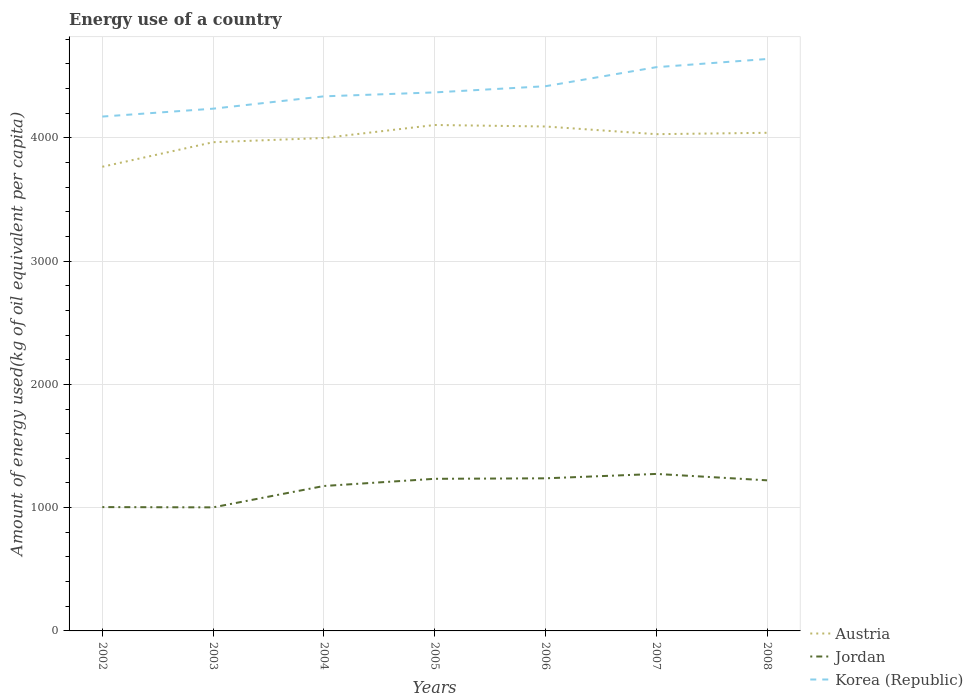Across all years, what is the maximum amount of energy used in in Korea (Republic)?
Ensure brevity in your answer.  4172.45. In which year was the amount of energy used in in Korea (Republic) maximum?
Make the answer very short. 2002. What is the total amount of energy used in in Austria in the graph?
Your answer should be very brief. -233.46. What is the difference between the highest and the second highest amount of energy used in in Jordan?
Your answer should be very brief. 271.25. Is the amount of energy used in in Jordan strictly greater than the amount of energy used in in Korea (Republic) over the years?
Provide a succinct answer. Yes. How many years are there in the graph?
Provide a short and direct response. 7. What is the title of the graph?
Provide a short and direct response. Energy use of a country. What is the label or title of the X-axis?
Your response must be concise. Years. What is the label or title of the Y-axis?
Your answer should be compact. Amount of energy used(kg of oil equivalent per capita). What is the Amount of energy used(kg of oil equivalent per capita) of Austria in 2002?
Give a very brief answer. 3765.28. What is the Amount of energy used(kg of oil equivalent per capita) of Jordan in 2002?
Keep it short and to the point. 1004.46. What is the Amount of energy used(kg of oil equivalent per capita) in Korea (Republic) in 2002?
Your answer should be very brief. 4172.45. What is the Amount of energy used(kg of oil equivalent per capita) of Austria in 2003?
Ensure brevity in your answer.  3964.42. What is the Amount of energy used(kg of oil equivalent per capita) in Jordan in 2003?
Keep it short and to the point. 1002.28. What is the Amount of energy used(kg of oil equivalent per capita) of Korea (Republic) in 2003?
Your answer should be compact. 4236.41. What is the Amount of energy used(kg of oil equivalent per capita) in Austria in 2004?
Your answer should be very brief. 3998.74. What is the Amount of energy used(kg of oil equivalent per capita) of Jordan in 2004?
Offer a terse response. 1175.68. What is the Amount of energy used(kg of oil equivalent per capita) in Korea (Republic) in 2004?
Offer a very short reply. 4336.56. What is the Amount of energy used(kg of oil equivalent per capita) of Austria in 2005?
Your answer should be very brief. 4104.07. What is the Amount of energy used(kg of oil equivalent per capita) of Jordan in 2005?
Provide a short and direct response. 1233.95. What is the Amount of energy used(kg of oil equivalent per capita) in Korea (Republic) in 2005?
Offer a very short reply. 4368.43. What is the Amount of energy used(kg of oil equivalent per capita) of Austria in 2006?
Provide a short and direct response. 4091.95. What is the Amount of energy used(kg of oil equivalent per capita) in Jordan in 2006?
Make the answer very short. 1237.89. What is the Amount of energy used(kg of oil equivalent per capita) in Korea (Republic) in 2006?
Keep it short and to the point. 4418.58. What is the Amount of energy used(kg of oil equivalent per capita) in Austria in 2007?
Provide a short and direct response. 4029.63. What is the Amount of energy used(kg of oil equivalent per capita) of Jordan in 2007?
Ensure brevity in your answer.  1273.53. What is the Amount of energy used(kg of oil equivalent per capita) in Korea (Republic) in 2007?
Offer a very short reply. 4573.06. What is the Amount of energy used(kg of oil equivalent per capita) of Austria in 2008?
Offer a very short reply. 4040.8. What is the Amount of energy used(kg of oil equivalent per capita) of Jordan in 2008?
Make the answer very short. 1221.67. What is the Amount of energy used(kg of oil equivalent per capita) in Korea (Republic) in 2008?
Your response must be concise. 4639.47. Across all years, what is the maximum Amount of energy used(kg of oil equivalent per capita) of Austria?
Keep it short and to the point. 4104.07. Across all years, what is the maximum Amount of energy used(kg of oil equivalent per capita) of Jordan?
Your answer should be compact. 1273.53. Across all years, what is the maximum Amount of energy used(kg of oil equivalent per capita) in Korea (Republic)?
Your answer should be compact. 4639.47. Across all years, what is the minimum Amount of energy used(kg of oil equivalent per capita) in Austria?
Make the answer very short. 3765.28. Across all years, what is the minimum Amount of energy used(kg of oil equivalent per capita) in Jordan?
Give a very brief answer. 1002.28. Across all years, what is the minimum Amount of energy used(kg of oil equivalent per capita) of Korea (Republic)?
Provide a succinct answer. 4172.45. What is the total Amount of energy used(kg of oil equivalent per capita) of Austria in the graph?
Give a very brief answer. 2.80e+04. What is the total Amount of energy used(kg of oil equivalent per capita) of Jordan in the graph?
Your answer should be very brief. 8149.47. What is the total Amount of energy used(kg of oil equivalent per capita) of Korea (Republic) in the graph?
Your answer should be very brief. 3.07e+04. What is the difference between the Amount of energy used(kg of oil equivalent per capita) of Austria in 2002 and that in 2003?
Provide a short and direct response. -199.14. What is the difference between the Amount of energy used(kg of oil equivalent per capita) in Jordan in 2002 and that in 2003?
Ensure brevity in your answer.  2.18. What is the difference between the Amount of energy used(kg of oil equivalent per capita) of Korea (Republic) in 2002 and that in 2003?
Give a very brief answer. -63.96. What is the difference between the Amount of energy used(kg of oil equivalent per capita) of Austria in 2002 and that in 2004?
Make the answer very short. -233.46. What is the difference between the Amount of energy used(kg of oil equivalent per capita) of Jordan in 2002 and that in 2004?
Give a very brief answer. -171.22. What is the difference between the Amount of energy used(kg of oil equivalent per capita) of Korea (Republic) in 2002 and that in 2004?
Offer a very short reply. -164.1. What is the difference between the Amount of energy used(kg of oil equivalent per capita) of Austria in 2002 and that in 2005?
Offer a very short reply. -338.79. What is the difference between the Amount of energy used(kg of oil equivalent per capita) in Jordan in 2002 and that in 2005?
Your answer should be very brief. -229.49. What is the difference between the Amount of energy used(kg of oil equivalent per capita) in Korea (Republic) in 2002 and that in 2005?
Offer a terse response. -195.98. What is the difference between the Amount of energy used(kg of oil equivalent per capita) of Austria in 2002 and that in 2006?
Offer a terse response. -326.66. What is the difference between the Amount of energy used(kg of oil equivalent per capita) in Jordan in 2002 and that in 2006?
Your answer should be very brief. -233.43. What is the difference between the Amount of energy used(kg of oil equivalent per capita) in Korea (Republic) in 2002 and that in 2006?
Your response must be concise. -246.13. What is the difference between the Amount of energy used(kg of oil equivalent per capita) of Austria in 2002 and that in 2007?
Give a very brief answer. -264.34. What is the difference between the Amount of energy used(kg of oil equivalent per capita) of Jordan in 2002 and that in 2007?
Your answer should be compact. -269.07. What is the difference between the Amount of energy used(kg of oil equivalent per capita) of Korea (Republic) in 2002 and that in 2007?
Make the answer very short. -400.61. What is the difference between the Amount of energy used(kg of oil equivalent per capita) in Austria in 2002 and that in 2008?
Offer a terse response. -275.51. What is the difference between the Amount of energy used(kg of oil equivalent per capita) in Jordan in 2002 and that in 2008?
Give a very brief answer. -217.21. What is the difference between the Amount of energy used(kg of oil equivalent per capita) in Korea (Republic) in 2002 and that in 2008?
Ensure brevity in your answer.  -467.02. What is the difference between the Amount of energy used(kg of oil equivalent per capita) in Austria in 2003 and that in 2004?
Your answer should be compact. -34.32. What is the difference between the Amount of energy used(kg of oil equivalent per capita) of Jordan in 2003 and that in 2004?
Ensure brevity in your answer.  -173.4. What is the difference between the Amount of energy used(kg of oil equivalent per capita) in Korea (Republic) in 2003 and that in 2004?
Keep it short and to the point. -100.15. What is the difference between the Amount of energy used(kg of oil equivalent per capita) of Austria in 2003 and that in 2005?
Your answer should be very brief. -139.65. What is the difference between the Amount of energy used(kg of oil equivalent per capita) of Jordan in 2003 and that in 2005?
Provide a short and direct response. -231.67. What is the difference between the Amount of energy used(kg of oil equivalent per capita) of Korea (Republic) in 2003 and that in 2005?
Your response must be concise. -132.03. What is the difference between the Amount of energy used(kg of oil equivalent per capita) in Austria in 2003 and that in 2006?
Provide a short and direct response. -127.53. What is the difference between the Amount of energy used(kg of oil equivalent per capita) in Jordan in 2003 and that in 2006?
Offer a very short reply. -235.61. What is the difference between the Amount of energy used(kg of oil equivalent per capita) of Korea (Republic) in 2003 and that in 2006?
Your answer should be very brief. -182.17. What is the difference between the Amount of energy used(kg of oil equivalent per capita) in Austria in 2003 and that in 2007?
Offer a very short reply. -65.21. What is the difference between the Amount of energy used(kg of oil equivalent per capita) of Jordan in 2003 and that in 2007?
Provide a succinct answer. -271.25. What is the difference between the Amount of energy used(kg of oil equivalent per capita) in Korea (Republic) in 2003 and that in 2007?
Ensure brevity in your answer.  -336.66. What is the difference between the Amount of energy used(kg of oil equivalent per capita) of Austria in 2003 and that in 2008?
Your answer should be compact. -76.38. What is the difference between the Amount of energy used(kg of oil equivalent per capita) of Jordan in 2003 and that in 2008?
Ensure brevity in your answer.  -219.38. What is the difference between the Amount of energy used(kg of oil equivalent per capita) of Korea (Republic) in 2003 and that in 2008?
Provide a succinct answer. -403.06. What is the difference between the Amount of energy used(kg of oil equivalent per capita) in Austria in 2004 and that in 2005?
Give a very brief answer. -105.33. What is the difference between the Amount of energy used(kg of oil equivalent per capita) in Jordan in 2004 and that in 2005?
Provide a succinct answer. -58.27. What is the difference between the Amount of energy used(kg of oil equivalent per capita) in Korea (Republic) in 2004 and that in 2005?
Make the answer very short. -31.88. What is the difference between the Amount of energy used(kg of oil equivalent per capita) in Austria in 2004 and that in 2006?
Make the answer very short. -93.21. What is the difference between the Amount of energy used(kg of oil equivalent per capita) of Jordan in 2004 and that in 2006?
Make the answer very short. -62.21. What is the difference between the Amount of energy used(kg of oil equivalent per capita) of Korea (Republic) in 2004 and that in 2006?
Provide a succinct answer. -82.02. What is the difference between the Amount of energy used(kg of oil equivalent per capita) of Austria in 2004 and that in 2007?
Make the answer very short. -30.89. What is the difference between the Amount of energy used(kg of oil equivalent per capita) of Jordan in 2004 and that in 2007?
Offer a very short reply. -97.85. What is the difference between the Amount of energy used(kg of oil equivalent per capita) of Korea (Republic) in 2004 and that in 2007?
Provide a short and direct response. -236.51. What is the difference between the Amount of energy used(kg of oil equivalent per capita) of Austria in 2004 and that in 2008?
Offer a very short reply. -42.06. What is the difference between the Amount of energy used(kg of oil equivalent per capita) of Jordan in 2004 and that in 2008?
Give a very brief answer. -45.98. What is the difference between the Amount of energy used(kg of oil equivalent per capita) in Korea (Republic) in 2004 and that in 2008?
Offer a terse response. -302.92. What is the difference between the Amount of energy used(kg of oil equivalent per capita) in Austria in 2005 and that in 2006?
Keep it short and to the point. 12.13. What is the difference between the Amount of energy used(kg of oil equivalent per capita) of Jordan in 2005 and that in 2006?
Your answer should be very brief. -3.94. What is the difference between the Amount of energy used(kg of oil equivalent per capita) of Korea (Republic) in 2005 and that in 2006?
Give a very brief answer. -50.15. What is the difference between the Amount of energy used(kg of oil equivalent per capita) in Austria in 2005 and that in 2007?
Offer a very short reply. 74.44. What is the difference between the Amount of energy used(kg of oil equivalent per capita) of Jordan in 2005 and that in 2007?
Ensure brevity in your answer.  -39.58. What is the difference between the Amount of energy used(kg of oil equivalent per capita) in Korea (Republic) in 2005 and that in 2007?
Provide a succinct answer. -204.63. What is the difference between the Amount of energy used(kg of oil equivalent per capita) of Austria in 2005 and that in 2008?
Your response must be concise. 63.27. What is the difference between the Amount of energy used(kg of oil equivalent per capita) in Jordan in 2005 and that in 2008?
Ensure brevity in your answer.  12.28. What is the difference between the Amount of energy used(kg of oil equivalent per capita) in Korea (Republic) in 2005 and that in 2008?
Provide a short and direct response. -271.04. What is the difference between the Amount of energy used(kg of oil equivalent per capita) of Austria in 2006 and that in 2007?
Your response must be concise. 62.32. What is the difference between the Amount of energy used(kg of oil equivalent per capita) of Jordan in 2006 and that in 2007?
Ensure brevity in your answer.  -35.64. What is the difference between the Amount of energy used(kg of oil equivalent per capita) in Korea (Republic) in 2006 and that in 2007?
Your answer should be compact. -154.49. What is the difference between the Amount of energy used(kg of oil equivalent per capita) of Austria in 2006 and that in 2008?
Provide a succinct answer. 51.15. What is the difference between the Amount of energy used(kg of oil equivalent per capita) in Jordan in 2006 and that in 2008?
Provide a succinct answer. 16.23. What is the difference between the Amount of energy used(kg of oil equivalent per capita) of Korea (Republic) in 2006 and that in 2008?
Give a very brief answer. -220.89. What is the difference between the Amount of energy used(kg of oil equivalent per capita) in Austria in 2007 and that in 2008?
Your answer should be very brief. -11.17. What is the difference between the Amount of energy used(kg of oil equivalent per capita) of Jordan in 2007 and that in 2008?
Your answer should be compact. 51.87. What is the difference between the Amount of energy used(kg of oil equivalent per capita) in Korea (Republic) in 2007 and that in 2008?
Make the answer very short. -66.41. What is the difference between the Amount of energy used(kg of oil equivalent per capita) of Austria in 2002 and the Amount of energy used(kg of oil equivalent per capita) of Jordan in 2003?
Your response must be concise. 2763. What is the difference between the Amount of energy used(kg of oil equivalent per capita) in Austria in 2002 and the Amount of energy used(kg of oil equivalent per capita) in Korea (Republic) in 2003?
Provide a succinct answer. -471.13. What is the difference between the Amount of energy used(kg of oil equivalent per capita) in Jordan in 2002 and the Amount of energy used(kg of oil equivalent per capita) in Korea (Republic) in 2003?
Provide a short and direct response. -3231.95. What is the difference between the Amount of energy used(kg of oil equivalent per capita) in Austria in 2002 and the Amount of energy used(kg of oil equivalent per capita) in Jordan in 2004?
Make the answer very short. 2589.6. What is the difference between the Amount of energy used(kg of oil equivalent per capita) of Austria in 2002 and the Amount of energy used(kg of oil equivalent per capita) of Korea (Republic) in 2004?
Provide a succinct answer. -571.27. What is the difference between the Amount of energy used(kg of oil equivalent per capita) of Jordan in 2002 and the Amount of energy used(kg of oil equivalent per capita) of Korea (Republic) in 2004?
Your response must be concise. -3332.1. What is the difference between the Amount of energy used(kg of oil equivalent per capita) of Austria in 2002 and the Amount of energy used(kg of oil equivalent per capita) of Jordan in 2005?
Provide a short and direct response. 2531.33. What is the difference between the Amount of energy used(kg of oil equivalent per capita) of Austria in 2002 and the Amount of energy used(kg of oil equivalent per capita) of Korea (Republic) in 2005?
Give a very brief answer. -603.15. What is the difference between the Amount of energy used(kg of oil equivalent per capita) in Jordan in 2002 and the Amount of energy used(kg of oil equivalent per capita) in Korea (Republic) in 2005?
Make the answer very short. -3363.97. What is the difference between the Amount of energy used(kg of oil equivalent per capita) of Austria in 2002 and the Amount of energy used(kg of oil equivalent per capita) of Jordan in 2006?
Provide a short and direct response. 2527.39. What is the difference between the Amount of energy used(kg of oil equivalent per capita) in Austria in 2002 and the Amount of energy used(kg of oil equivalent per capita) in Korea (Republic) in 2006?
Your answer should be very brief. -653.3. What is the difference between the Amount of energy used(kg of oil equivalent per capita) of Jordan in 2002 and the Amount of energy used(kg of oil equivalent per capita) of Korea (Republic) in 2006?
Make the answer very short. -3414.12. What is the difference between the Amount of energy used(kg of oil equivalent per capita) of Austria in 2002 and the Amount of energy used(kg of oil equivalent per capita) of Jordan in 2007?
Keep it short and to the point. 2491.75. What is the difference between the Amount of energy used(kg of oil equivalent per capita) of Austria in 2002 and the Amount of energy used(kg of oil equivalent per capita) of Korea (Republic) in 2007?
Provide a succinct answer. -807.78. What is the difference between the Amount of energy used(kg of oil equivalent per capita) of Jordan in 2002 and the Amount of energy used(kg of oil equivalent per capita) of Korea (Republic) in 2007?
Provide a succinct answer. -3568.61. What is the difference between the Amount of energy used(kg of oil equivalent per capita) in Austria in 2002 and the Amount of energy used(kg of oil equivalent per capita) in Jordan in 2008?
Keep it short and to the point. 2543.62. What is the difference between the Amount of energy used(kg of oil equivalent per capita) in Austria in 2002 and the Amount of energy used(kg of oil equivalent per capita) in Korea (Republic) in 2008?
Provide a short and direct response. -874.19. What is the difference between the Amount of energy used(kg of oil equivalent per capita) of Jordan in 2002 and the Amount of energy used(kg of oil equivalent per capita) of Korea (Republic) in 2008?
Ensure brevity in your answer.  -3635.01. What is the difference between the Amount of energy used(kg of oil equivalent per capita) in Austria in 2003 and the Amount of energy used(kg of oil equivalent per capita) in Jordan in 2004?
Offer a terse response. 2788.74. What is the difference between the Amount of energy used(kg of oil equivalent per capita) in Austria in 2003 and the Amount of energy used(kg of oil equivalent per capita) in Korea (Republic) in 2004?
Offer a terse response. -372.14. What is the difference between the Amount of energy used(kg of oil equivalent per capita) in Jordan in 2003 and the Amount of energy used(kg of oil equivalent per capita) in Korea (Republic) in 2004?
Offer a terse response. -3334.27. What is the difference between the Amount of energy used(kg of oil equivalent per capita) in Austria in 2003 and the Amount of energy used(kg of oil equivalent per capita) in Jordan in 2005?
Offer a terse response. 2730.47. What is the difference between the Amount of energy used(kg of oil equivalent per capita) of Austria in 2003 and the Amount of energy used(kg of oil equivalent per capita) of Korea (Republic) in 2005?
Provide a short and direct response. -404.01. What is the difference between the Amount of energy used(kg of oil equivalent per capita) of Jordan in 2003 and the Amount of energy used(kg of oil equivalent per capita) of Korea (Republic) in 2005?
Offer a terse response. -3366.15. What is the difference between the Amount of energy used(kg of oil equivalent per capita) of Austria in 2003 and the Amount of energy used(kg of oil equivalent per capita) of Jordan in 2006?
Keep it short and to the point. 2726.52. What is the difference between the Amount of energy used(kg of oil equivalent per capita) in Austria in 2003 and the Amount of energy used(kg of oil equivalent per capita) in Korea (Republic) in 2006?
Your answer should be very brief. -454.16. What is the difference between the Amount of energy used(kg of oil equivalent per capita) of Jordan in 2003 and the Amount of energy used(kg of oil equivalent per capita) of Korea (Republic) in 2006?
Give a very brief answer. -3416.3. What is the difference between the Amount of energy used(kg of oil equivalent per capita) in Austria in 2003 and the Amount of energy used(kg of oil equivalent per capita) in Jordan in 2007?
Your response must be concise. 2690.89. What is the difference between the Amount of energy used(kg of oil equivalent per capita) of Austria in 2003 and the Amount of energy used(kg of oil equivalent per capita) of Korea (Republic) in 2007?
Keep it short and to the point. -608.65. What is the difference between the Amount of energy used(kg of oil equivalent per capita) of Jordan in 2003 and the Amount of energy used(kg of oil equivalent per capita) of Korea (Republic) in 2007?
Provide a succinct answer. -3570.78. What is the difference between the Amount of energy used(kg of oil equivalent per capita) of Austria in 2003 and the Amount of energy used(kg of oil equivalent per capita) of Jordan in 2008?
Your answer should be compact. 2742.75. What is the difference between the Amount of energy used(kg of oil equivalent per capita) of Austria in 2003 and the Amount of energy used(kg of oil equivalent per capita) of Korea (Republic) in 2008?
Keep it short and to the point. -675.05. What is the difference between the Amount of energy used(kg of oil equivalent per capita) of Jordan in 2003 and the Amount of energy used(kg of oil equivalent per capita) of Korea (Republic) in 2008?
Your answer should be compact. -3637.19. What is the difference between the Amount of energy used(kg of oil equivalent per capita) in Austria in 2004 and the Amount of energy used(kg of oil equivalent per capita) in Jordan in 2005?
Your answer should be compact. 2764.79. What is the difference between the Amount of energy used(kg of oil equivalent per capita) in Austria in 2004 and the Amount of energy used(kg of oil equivalent per capita) in Korea (Republic) in 2005?
Offer a very short reply. -369.69. What is the difference between the Amount of energy used(kg of oil equivalent per capita) of Jordan in 2004 and the Amount of energy used(kg of oil equivalent per capita) of Korea (Republic) in 2005?
Give a very brief answer. -3192.75. What is the difference between the Amount of energy used(kg of oil equivalent per capita) in Austria in 2004 and the Amount of energy used(kg of oil equivalent per capita) in Jordan in 2006?
Keep it short and to the point. 2760.84. What is the difference between the Amount of energy used(kg of oil equivalent per capita) of Austria in 2004 and the Amount of energy used(kg of oil equivalent per capita) of Korea (Republic) in 2006?
Offer a terse response. -419.84. What is the difference between the Amount of energy used(kg of oil equivalent per capita) in Jordan in 2004 and the Amount of energy used(kg of oil equivalent per capita) in Korea (Republic) in 2006?
Your answer should be compact. -3242.9. What is the difference between the Amount of energy used(kg of oil equivalent per capita) of Austria in 2004 and the Amount of energy used(kg of oil equivalent per capita) of Jordan in 2007?
Offer a very short reply. 2725.21. What is the difference between the Amount of energy used(kg of oil equivalent per capita) of Austria in 2004 and the Amount of energy used(kg of oil equivalent per capita) of Korea (Republic) in 2007?
Give a very brief answer. -574.33. What is the difference between the Amount of energy used(kg of oil equivalent per capita) of Jordan in 2004 and the Amount of energy used(kg of oil equivalent per capita) of Korea (Republic) in 2007?
Provide a succinct answer. -3397.38. What is the difference between the Amount of energy used(kg of oil equivalent per capita) of Austria in 2004 and the Amount of energy used(kg of oil equivalent per capita) of Jordan in 2008?
Your answer should be very brief. 2777.07. What is the difference between the Amount of energy used(kg of oil equivalent per capita) in Austria in 2004 and the Amount of energy used(kg of oil equivalent per capita) in Korea (Republic) in 2008?
Keep it short and to the point. -640.73. What is the difference between the Amount of energy used(kg of oil equivalent per capita) in Jordan in 2004 and the Amount of energy used(kg of oil equivalent per capita) in Korea (Republic) in 2008?
Your answer should be very brief. -3463.79. What is the difference between the Amount of energy used(kg of oil equivalent per capita) in Austria in 2005 and the Amount of energy used(kg of oil equivalent per capita) in Jordan in 2006?
Your answer should be compact. 2866.18. What is the difference between the Amount of energy used(kg of oil equivalent per capita) in Austria in 2005 and the Amount of energy used(kg of oil equivalent per capita) in Korea (Republic) in 2006?
Your response must be concise. -314.51. What is the difference between the Amount of energy used(kg of oil equivalent per capita) in Jordan in 2005 and the Amount of energy used(kg of oil equivalent per capita) in Korea (Republic) in 2006?
Offer a terse response. -3184.63. What is the difference between the Amount of energy used(kg of oil equivalent per capita) of Austria in 2005 and the Amount of energy used(kg of oil equivalent per capita) of Jordan in 2007?
Make the answer very short. 2830.54. What is the difference between the Amount of energy used(kg of oil equivalent per capita) of Austria in 2005 and the Amount of energy used(kg of oil equivalent per capita) of Korea (Republic) in 2007?
Make the answer very short. -468.99. What is the difference between the Amount of energy used(kg of oil equivalent per capita) of Jordan in 2005 and the Amount of energy used(kg of oil equivalent per capita) of Korea (Republic) in 2007?
Provide a succinct answer. -3339.11. What is the difference between the Amount of energy used(kg of oil equivalent per capita) in Austria in 2005 and the Amount of energy used(kg of oil equivalent per capita) in Jordan in 2008?
Offer a very short reply. 2882.41. What is the difference between the Amount of energy used(kg of oil equivalent per capita) of Austria in 2005 and the Amount of energy used(kg of oil equivalent per capita) of Korea (Republic) in 2008?
Offer a very short reply. -535.4. What is the difference between the Amount of energy used(kg of oil equivalent per capita) in Jordan in 2005 and the Amount of energy used(kg of oil equivalent per capita) in Korea (Republic) in 2008?
Your response must be concise. -3405.52. What is the difference between the Amount of energy used(kg of oil equivalent per capita) of Austria in 2006 and the Amount of energy used(kg of oil equivalent per capita) of Jordan in 2007?
Provide a succinct answer. 2818.41. What is the difference between the Amount of energy used(kg of oil equivalent per capita) in Austria in 2006 and the Amount of energy used(kg of oil equivalent per capita) in Korea (Republic) in 2007?
Keep it short and to the point. -481.12. What is the difference between the Amount of energy used(kg of oil equivalent per capita) of Jordan in 2006 and the Amount of energy used(kg of oil equivalent per capita) of Korea (Republic) in 2007?
Give a very brief answer. -3335.17. What is the difference between the Amount of energy used(kg of oil equivalent per capita) in Austria in 2006 and the Amount of energy used(kg of oil equivalent per capita) in Jordan in 2008?
Provide a succinct answer. 2870.28. What is the difference between the Amount of energy used(kg of oil equivalent per capita) in Austria in 2006 and the Amount of energy used(kg of oil equivalent per capita) in Korea (Republic) in 2008?
Provide a short and direct response. -547.52. What is the difference between the Amount of energy used(kg of oil equivalent per capita) in Jordan in 2006 and the Amount of energy used(kg of oil equivalent per capita) in Korea (Republic) in 2008?
Give a very brief answer. -3401.58. What is the difference between the Amount of energy used(kg of oil equivalent per capita) in Austria in 2007 and the Amount of energy used(kg of oil equivalent per capita) in Jordan in 2008?
Make the answer very short. 2807.96. What is the difference between the Amount of energy used(kg of oil equivalent per capita) in Austria in 2007 and the Amount of energy used(kg of oil equivalent per capita) in Korea (Republic) in 2008?
Offer a terse response. -609.84. What is the difference between the Amount of energy used(kg of oil equivalent per capita) in Jordan in 2007 and the Amount of energy used(kg of oil equivalent per capita) in Korea (Republic) in 2008?
Provide a succinct answer. -3365.94. What is the average Amount of energy used(kg of oil equivalent per capita) in Austria per year?
Offer a terse response. 3999.27. What is the average Amount of energy used(kg of oil equivalent per capita) in Jordan per year?
Your response must be concise. 1164.21. What is the average Amount of energy used(kg of oil equivalent per capita) of Korea (Republic) per year?
Make the answer very short. 4392.14. In the year 2002, what is the difference between the Amount of energy used(kg of oil equivalent per capita) in Austria and Amount of energy used(kg of oil equivalent per capita) in Jordan?
Your response must be concise. 2760.82. In the year 2002, what is the difference between the Amount of energy used(kg of oil equivalent per capita) in Austria and Amount of energy used(kg of oil equivalent per capita) in Korea (Republic)?
Make the answer very short. -407.17. In the year 2002, what is the difference between the Amount of energy used(kg of oil equivalent per capita) in Jordan and Amount of energy used(kg of oil equivalent per capita) in Korea (Republic)?
Offer a very short reply. -3167.99. In the year 2003, what is the difference between the Amount of energy used(kg of oil equivalent per capita) in Austria and Amount of energy used(kg of oil equivalent per capita) in Jordan?
Offer a very short reply. 2962.14. In the year 2003, what is the difference between the Amount of energy used(kg of oil equivalent per capita) of Austria and Amount of energy used(kg of oil equivalent per capita) of Korea (Republic)?
Offer a terse response. -271.99. In the year 2003, what is the difference between the Amount of energy used(kg of oil equivalent per capita) in Jordan and Amount of energy used(kg of oil equivalent per capita) in Korea (Republic)?
Your answer should be compact. -3234.13. In the year 2004, what is the difference between the Amount of energy used(kg of oil equivalent per capita) in Austria and Amount of energy used(kg of oil equivalent per capita) in Jordan?
Your answer should be very brief. 2823.06. In the year 2004, what is the difference between the Amount of energy used(kg of oil equivalent per capita) in Austria and Amount of energy used(kg of oil equivalent per capita) in Korea (Republic)?
Provide a short and direct response. -337.82. In the year 2004, what is the difference between the Amount of energy used(kg of oil equivalent per capita) of Jordan and Amount of energy used(kg of oil equivalent per capita) of Korea (Republic)?
Offer a terse response. -3160.87. In the year 2005, what is the difference between the Amount of energy used(kg of oil equivalent per capita) in Austria and Amount of energy used(kg of oil equivalent per capita) in Jordan?
Ensure brevity in your answer.  2870.12. In the year 2005, what is the difference between the Amount of energy used(kg of oil equivalent per capita) of Austria and Amount of energy used(kg of oil equivalent per capita) of Korea (Republic)?
Your answer should be compact. -264.36. In the year 2005, what is the difference between the Amount of energy used(kg of oil equivalent per capita) of Jordan and Amount of energy used(kg of oil equivalent per capita) of Korea (Republic)?
Your response must be concise. -3134.48. In the year 2006, what is the difference between the Amount of energy used(kg of oil equivalent per capita) of Austria and Amount of energy used(kg of oil equivalent per capita) of Jordan?
Keep it short and to the point. 2854.05. In the year 2006, what is the difference between the Amount of energy used(kg of oil equivalent per capita) of Austria and Amount of energy used(kg of oil equivalent per capita) of Korea (Republic)?
Your answer should be compact. -326.63. In the year 2006, what is the difference between the Amount of energy used(kg of oil equivalent per capita) in Jordan and Amount of energy used(kg of oil equivalent per capita) in Korea (Republic)?
Give a very brief answer. -3180.69. In the year 2007, what is the difference between the Amount of energy used(kg of oil equivalent per capita) in Austria and Amount of energy used(kg of oil equivalent per capita) in Jordan?
Your response must be concise. 2756.1. In the year 2007, what is the difference between the Amount of energy used(kg of oil equivalent per capita) of Austria and Amount of energy used(kg of oil equivalent per capita) of Korea (Republic)?
Your answer should be compact. -543.44. In the year 2007, what is the difference between the Amount of energy used(kg of oil equivalent per capita) of Jordan and Amount of energy used(kg of oil equivalent per capita) of Korea (Republic)?
Make the answer very short. -3299.53. In the year 2008, what is the difference between the Amount of energy used(kg of oil equivalent per capita) in Austria and Amount of energy used(kg of oil equivalent per capita) in Jordan?
Make the answer very short. 2819.13. In the year 2008, what is the difference between the Amount of energy used(kg of oil equivalent per capita) of Austria and Amount of energy used(kg of oil equivalent per capita) of Korea (Republic)?
Provide a succinct answer. -598.67. In the year 2008, what is the difference between the Amount of energy used(kg of oil equivalent per capita) in Jordan and Amount of energy used(kg of oil equivalent per capita) in Korea (Republic)?
Keep it short and to the point. -3417.8. What is the ratio of the Amount of energy used(kg of oil equivalent per capita) in Austria in 2002 to that in 2003?
Provide a succinct answer. 0.95. What is the ratio of the Amount of energy used(kg of oil equivalent per capita) in Jordan in 2002 to that in 2003?
Make the answer very short. 1. What is the ratio of the Amount of energy used(kg of oil equivalent per capita) of Korea (Republic) in 2002 to that in 2003?
Provide a short and direct response. 0.98. What is the ratio of the Amount of energy used(kg of oil equivalent per capita) of Austria in 2002 to that in 2004?
Give a very brief answer. 0.94. What is the ratio of the Amount of energy used(kg of oil equivalent per capita) of Jordan in 2002 to that in 2004?
Keep it short and to the point. 0.85. What is the ratio of the Amount of energy used(kg of oil equivalent per capita) of Korea (Republic) in 2002 to that in 2004?
Offer a very short reply. 0.96. What is the ratio of the Amount of energy used(kg of oil equivalent per capita) of Austria in 2002 to that in 2005?
Keep it short and to the point. 0.92. What is the ratio of the Amount of energy used(kg of oil equivalent per capita) in Jordan in 2002 to that in 2005?
Keep it short and to the point. 0.81. What is the ratio of the Amount of energy used(kg of oil equivalent per capita) of Korea (Republic) in 2002 to that in 2005?
Your answer should be compact. 0.96. What is the ratio of the Amount of energy used(kg of oil equivalent per capita) of Austria in 2002 to that in 2006?
Give a very brief answer. 0.92. What is the ratio of the Amount of energy used(kg of oil equivalent per capita) in Jordan in 2002 to that in 2006?
Your response must be concise. 0.81. What is the ratio of the Amount of energy used(kg of oil equivalent per capita) in Korea (Republic) in 2002 to that in 2006?
Offer a terse response. 0.94. What is the ratio of the Amount of energy used(kg of oil equivalent per capita) in Austria in 2002 to that in 2007?
Make the answer very short. 0.93. What is the ratio of the Amount of energy used(kg of oil equivalent per capita) of Jordan in 2002 to that in 2007?
Keep it short and to the point. 0.79. What is the ratio of the Amount of energy used(kg of oil equivalent per capita) of Korea (Republic) in 2002 to that in 2007?
Give a very brief answer. 0.91. What is the ratio of the Amount of energy used(kg of oil equivalent per capita) in Austria in 2002 to that in 2008?
Your answer should be compact. 0.93. What is the ratio of the Amount of energy used(kg of oil equivalent per capita) in Jordan in 2002 to that in 2008?
Offer a terse response. 0.82. What is the ratio of the Amount of energy used(kg of oil equivalent per capita) of Korea (Republic) in 2002 to that in 2008?
Ensure brevity in your answer.  0.9. What is the ratio of the Amount of energy used(kg of oil equivalent per capita) in Austria in 2003 to that in 2004?
Keep it short and to the point. 0.99. What is the ratio of the Amount of energy used(kg of oil equivalent per capita) of Jordan in 2003 to that in 2004?
Offer a terse response. 0.85. What is the ratio of the Amount of energy used(kg of oil equivalent per capita) in Korea (Republic) in 2003 to that in 2004?
Give a very brief answer. 0.98. What is the ratio of the Amount of energy used(kg of oil equivalent per capita) in Austria in 2003 to that in 2005?
Your answer should be compact. 0.97. What is the ratio of the Amount of energy used(kg of oil equivalent per capita) of Jordan in 2003 to that in 2005?
Ensure brevity in your answer.  0.81. What is the ratio of the Amount of energy used(kg of oil equivalent per capita) of Korea (Republic) in 2003 to that in 2005?
Give a very brief answer. 0.97. What is the ratio of the Amount of energy used(kg of oil equivalent per capita) in Austria in 2003 to that in 2006?
Your response must be concise. 0.97. What is the ratio of the Amount of energy used(kg of oil equivalent per capita) of Jordan in 2003 to that in 2006?
Your response must be concise. 0.81. What is the ratio of the Amount of energy used(kg of oil equivalent per capita) of Korea (Republic) in 2003 to that in 2006?
Your answer should be compact. 0.96. What is the ratio of the Amount of energy used(kg of oil equivalent per capita) of Austria in 2003 to that in 2007?
Your response must be concise. 0.98. What is the ratio of the Amount of energy used(kg of oil equivalent per capita) in Jordan in 2003 to that in 2007?
Ensure brevity in your answer.  0.79. What is the ratio of the Amount of energy used(kg of oil equivalent per capita) of Korea (Republic) in 2003 to that in 2007?
Give a very brief answer. 0.93. What is the ratio of the Amount of energy used(kg of oil equivalent per capita) of Austria in 2003 to that in 2008?
Offer a very short reply. 0.98. What is the ratio of the Amount of energy used(kg of oil equivalent per capita) of Jordan in 2003 to that in 2008?
Offer a very short reply. 0.82. What is the ratio of the Amount of energy used(kg of oil equivalent per capita) in Korea (Republic) in 2003 to that in 2008?
Give a very brief answer. 0.91. What is the ratio of the Amount of energy used(kg of oil equivalent per capita) of Austria in 2004 to that in 2005?
Offer a very short reply. 0.97. What is the ratio of the Amount of energy used(kg of oil equivalent per capita) in Jordan in 2004 to that in 2005?
Provide a short and direct response. 0.95. What is the ratio of the Amount of energy used(kg of oil equivalent per capita) in Austria in 2004 to that in 2006?
Offer a terse response. 0.98. What is the ratio of the Amount of energy used(kg of oil equivalent per capita) of Jordan in 2004 to that in 2006?
Your response must be concise. 0.95. What is the ratio of the Amount of energy used(kg of oil equivalent per capita) in Korea (Republic) in 2004 to that in 2006?
Ensure brevity in your answer.  0.98. What is the ratio of the Amount of energy used(kg of oil equivalent per capita) in Jordan in 2004 to that in 2007?
Offer a terse response. 0.92. What is the ratio of the Amount of energy used(kg of oil equivalent per capita) of Korea (Republic) in 2004 to that in 2007?
Provide a succinct answer. 0.95. What is the ratio of the Amount of energy used(kg of oil equivalent per capita) in Jordan in 2004 to that in 2008?
Your answer should be compact. 0.96. What is the ratio of the Amount of energy used(kg of oil equivalent per capita) in Korea (Republic) in 2004 to that in 2008?
Your response must be concise. 0.93. What is the ratio of the Amount of energy used(kg of oil equivalent per capita) in Austria in 2005 to that in 2006?
Your answer should be compact. 1. What is the ratio of the Amount of energy used(kg of oil equivalent per capita) in Jordan in 2005 to that in 2006?
Your answer should be compact. 1. What is the ratio of the Amount of energy used(kg of oil equivalent per capita) of Korea (Republic) in 2005 to that in 2006?
Your answer should be very brief. 0.99. What is the ratio of the Amount of energy used(kg of oil equivalent per capita) in Austria in 2005 to that in 2007?
Offer a terse response. 1.02. What is the ratio of the Amount of energy used(kg of oil equivalent per capita) in Jordan in 2005 to that in 2007?
Provide a succinct answer. 0.97. What is the ratio of the Amount of energy used(kg of oil equivalent per capita) of Korea (Republic) in 2005 to that in 2007?
Provide a short and direct response. 0.96. What is the ratio of the Amount of energy used(kg of oil equivalent per capita) of Austria in 2005 to that in 2008?
Offer a very short reply. 1.02. What is the ratio of the Amount of energy used(kg of oil equivalent per capita) in Jordan in 2005 to that in 2008?
Provide a short and direct response. 1.01. What is the ratio of the Amount of energy used(kg of oil equivalent per capita) in Korea (Republic) in 2005 to that in 2008?
Ensure brevity in your answer.  0.94. What is the ratio of the Amount of energy used(kg of oil equivalent per capita) of Austria in 2006 to that in 2007?
Ensure brevity in your answer.  1.02. What is the ratio of the Amount of energy used(kg of oil equivalent per capita) in Jordan in 2006 to that in 2007?
Your answer should be compact. 0.97. What is the ratio of the Amount of energy used(kg of oil equivalent per capita) in Korea (Republic) in 2006 to that in 2007?
Give a very brief answer. 0.97. What is the ratio of the Amount of energy used(kg of oil equivalent per capita) in Austria in 2006 to that in 2008?
Give a very brief answer. 1.01. What is the ratio of the Amount of energy used(kg of oil equivalent per capita) in Jordan in 2006 to that in 2008?
Provide a short and direct response. 1.01. What is the ratio of the Amount of energy used(kg of oil equivalent per capita) in Korea (Republic) in 2006 to that in 2008?
Your response must be concise. 0.95. What is the ratio of the Amount of energy used(kg of oil equivalent per capita) in Austria in 2007 to that in 2008?
Your answer should be compact. 1. What is the ratio of the Amount of energy used(kg of oil equivalent per capita) of Jordan in 2007 to that in 2008?
Make the answer very short. 1.04. What is the ratio of the Amount of energy used(kg of oil equivalent per capita) in Korea (Republic) in 2007 to that in 2008?
Your answer should be compact. 0.99. What is the difference between the highest and the second highest Amount of energy used(kg of oil equivalent per capita) of Austria?
Keep it short and to the point. 12.13. What is the difference between the highest and the second highest Amount of energy used(kg of oil equivalent per capita) of Jordan?
Your answer should be compact. 35.64. What is the difference between the highest and the second highest Amount of energy used(kg of oil equivalent per capita) in Korea (Republic)?
Provide a succinct answer. 66.41. What is the difference between the highest and the lowest Amount of energy used(kg of oil equivalent per capita) in Austria?
Your response must be concise. 338.79. What is the difference between the highest and the lowest Amount of energy used(kg of oil equivalent per capita) in Jordan?
Your response must be concise. 271.25. What is the difference between the highest and the lowest Amount of energy used(kg of oil equivalent per capita) of Korea (Republic)?
Your response must be concise. 467.02. 